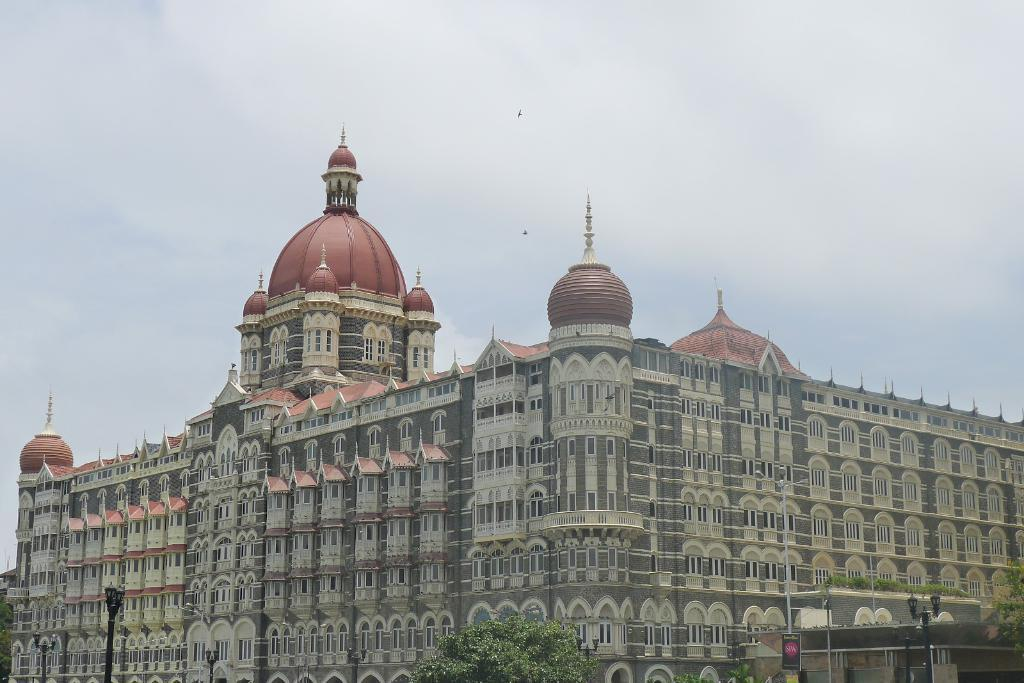What is the main structure in the center of the image? There is a building in the center of the image. What can be seen at the bottom of the image? There are street lights, trees, a signal, and another building at the bottom of the image. How would you describe the sky in the image? The sky is cloudy in the image. What is your sister doing in the image? There is no reference to a sister in the image, so it is not possible to answer that question. 